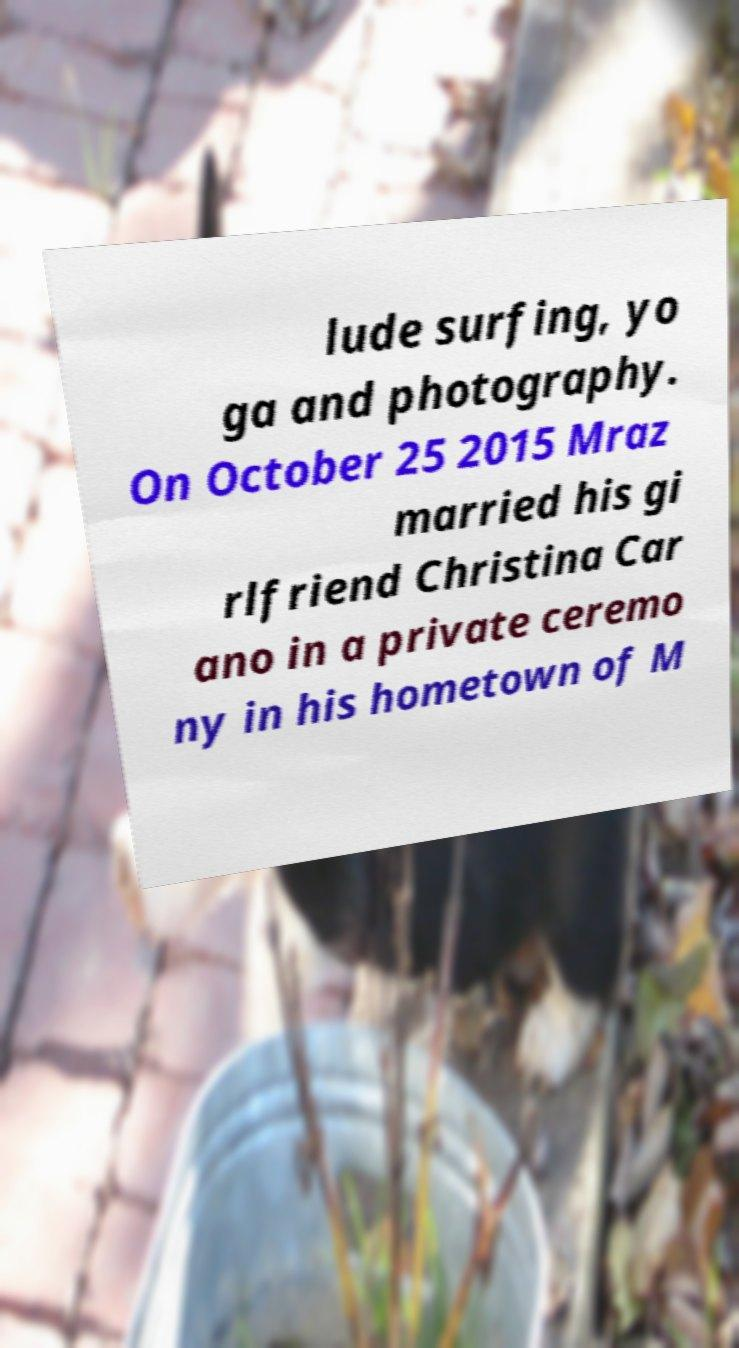There's text embedded in this image that I need extracted. Can you transcribe it verbatim? lude surfing, yo ga and photography. On October 25 2015 Mraz married his gi rlfriend Christina Car ano in a private ceremo ny in his hometown of M 